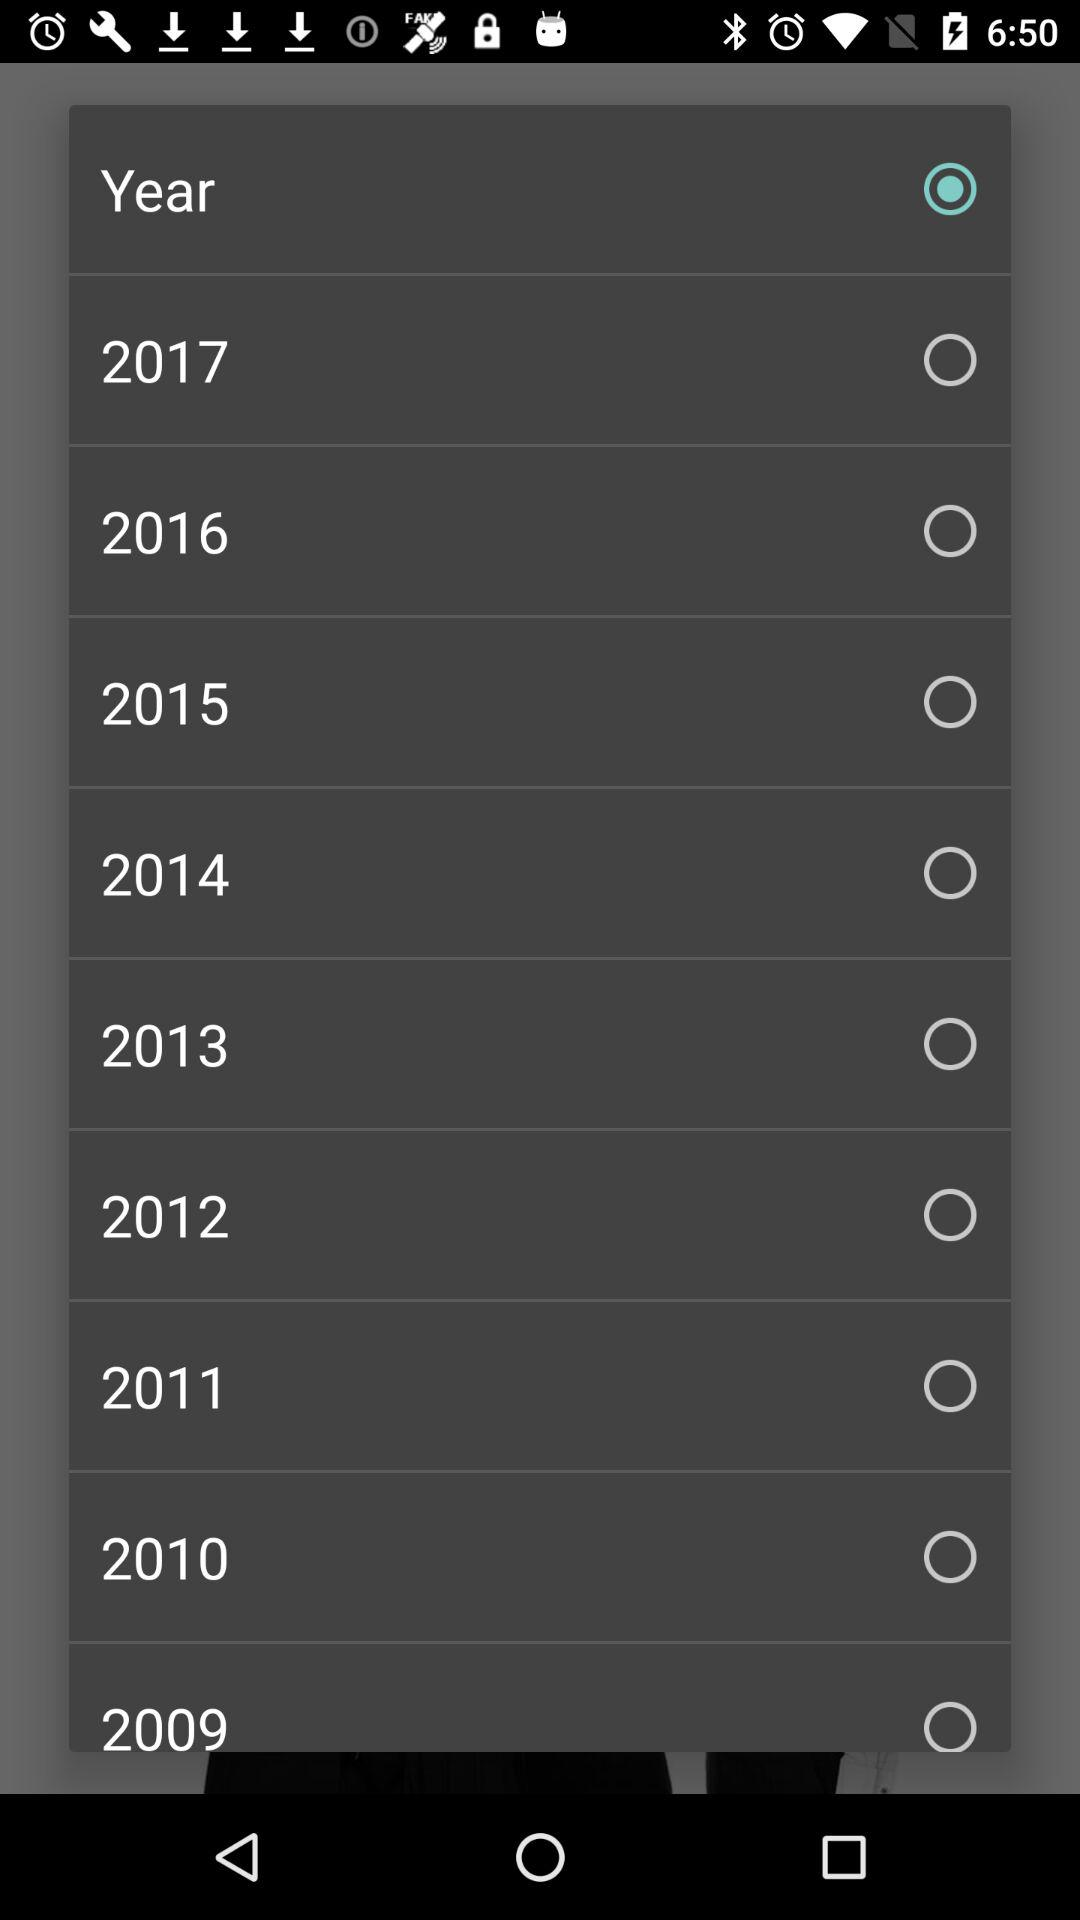Which year is selected?
When the provided information is insufficient, respond with <no answer>. <no answer> 